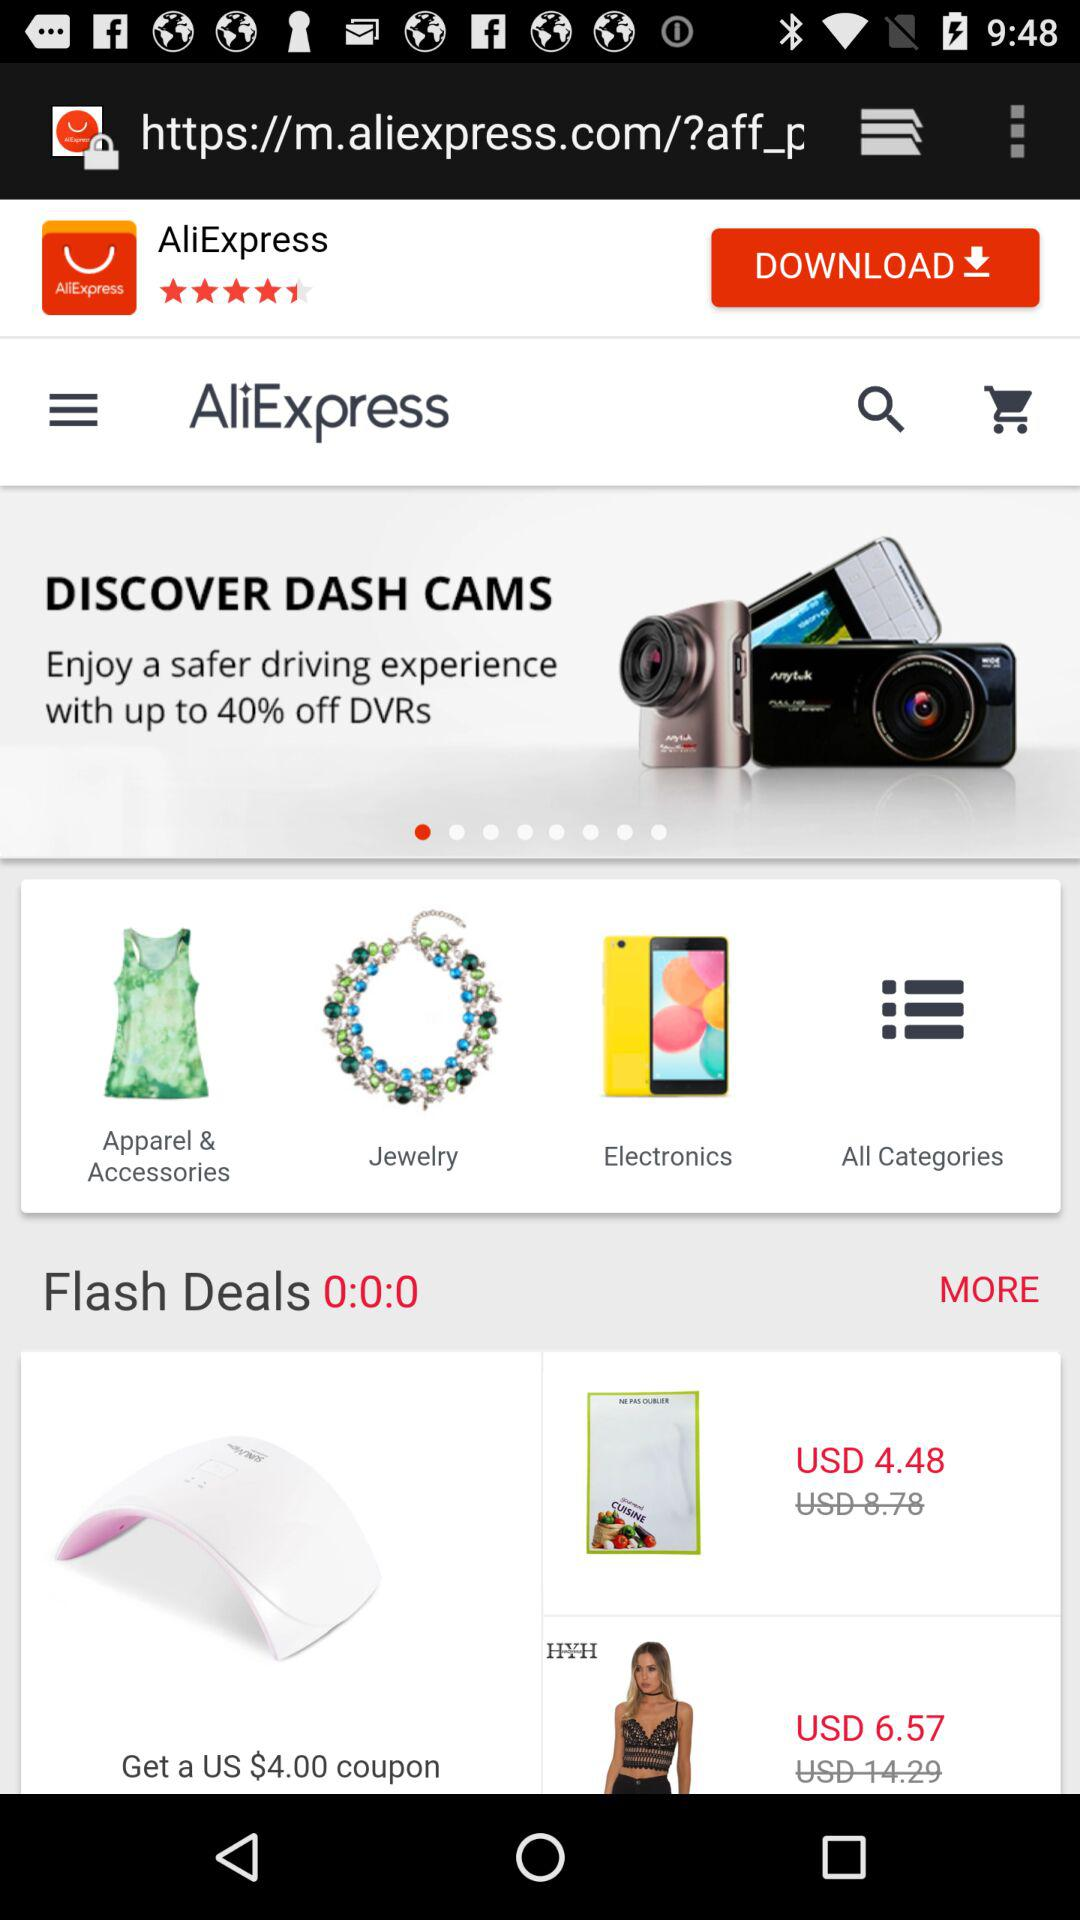How much time is remaining for flash sales? The remaining time for flash sales is 0 seconds. 